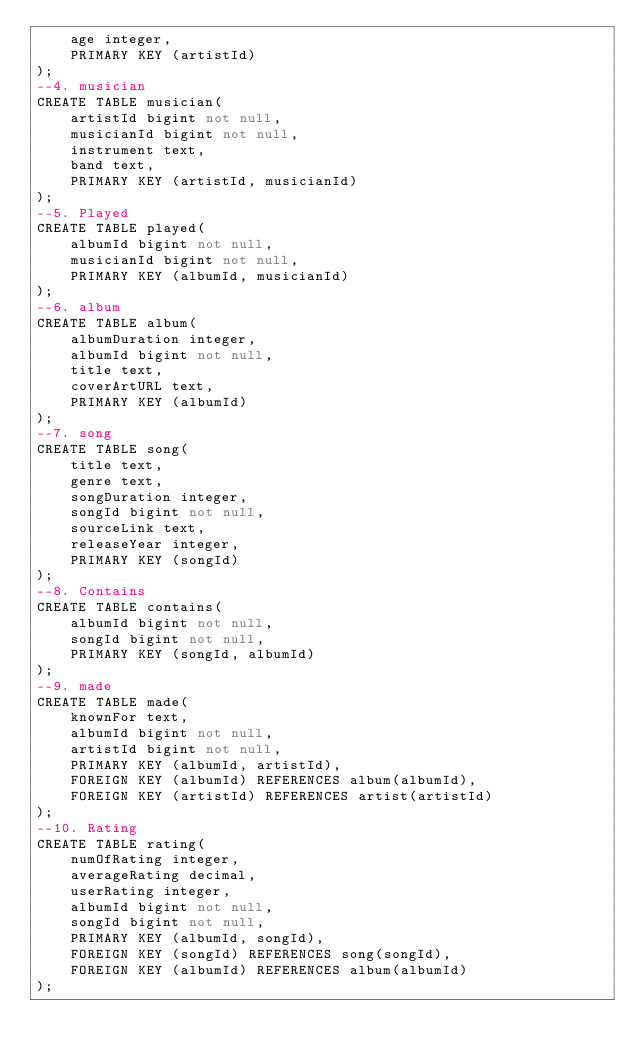<code> <loc_0><loc_0><loc_500><loc_500><_SQL_>    age integer,
    PRIMARY KEY (artistId)
);
--4. musician
CREATE TABLE musician(
    artistId bigint not null,
    musicianId bigint not null,
    instrument text,
    band text,
    PRIMARY KEY (artistId, musicianId)
);
--5. Played
CREATE TABLE played(
    albumId bigint not null,
    musicianId bigint not null,
    PRIMARY KEY (albumId, musicianId)
);
--6. album
CREATE TABLE album(
    albumDuration integer,
    albumId bigint not null,
    title text,
    coverArtURL text,
    PRIMARY KEY (albumId)
);
--7. song
CREATE TABLE song(
    title text,
    genre text,
    songDuration integer,
    songId bigint not null,
    sourceLink text,
    releaseYear integer,
    PRIMARY KEY (songId)
);
--8. Contains
CREATE TABLE contains(
    albumId bigint not null,
    songId bigint not null,
    PRIMARY KEY (songId, albumId)
);
--9. made
CREATE TABLE made(
    knownFor text,
    albumId bigint not null,
    artistId bigint not null,
    PRIMARY KEY (albumId, artistId),
    FOREIGN KEY (albumId) REFERENCES album(albumId),
    FOREIGN KEY (artistId) REFERENCES artist(artistId)
);
--10. Rating
CREATE TABLE rating(
    numOfRating integer,
    averageRating decimal,
    userRating integer,
    albumId bigint not null,
    songId bigint not null,
    PRIMARY KEY (albumId, songId),
    FOREIGN KEY (songId) REFERENCES song(songId),
    FOREIGN KEY (albumId) REFERENCES album(albumId)
);</code> 